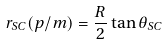<formula> <loc_0><loc_0><loc_500><loc_500>r _ { S C } ( p / m ) = \frac { R } { 2 } \tan \theta _ { S C }</formula> 